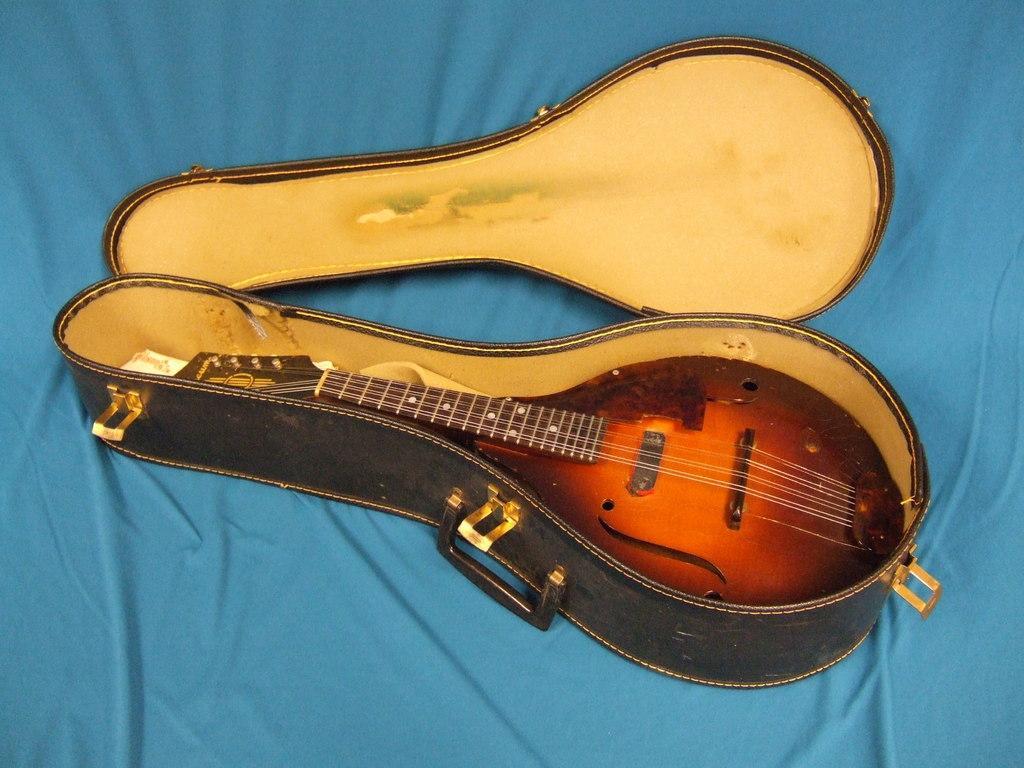Could you give a brief overview of what you see in this image? A mandolin is kept in its box. The lid is beside it. 